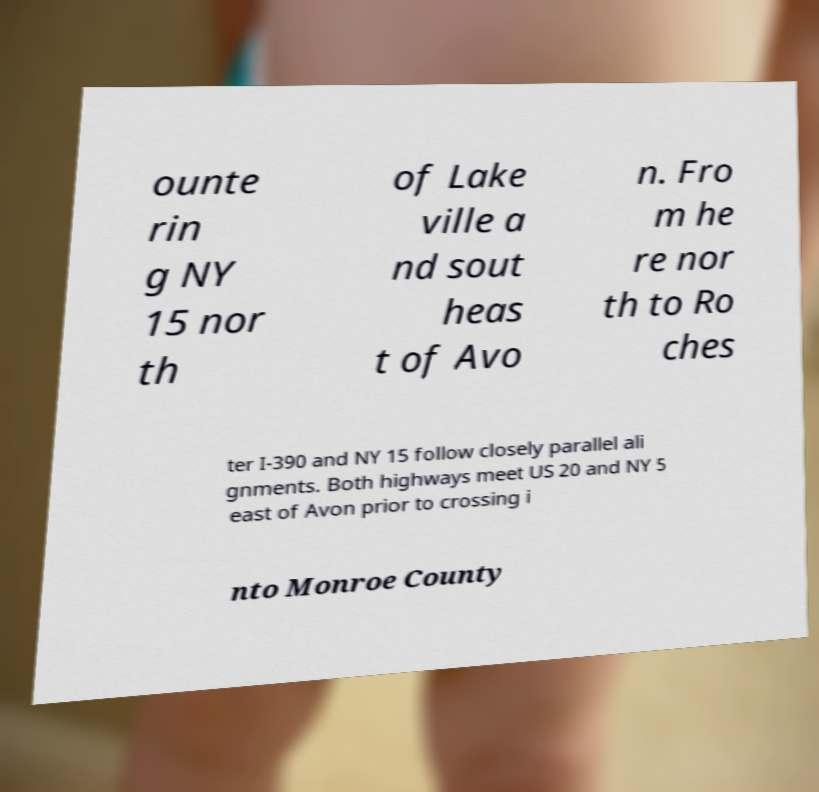Can you read and provide the text displayed in the image?This photo seems to have some interesting text. Can you extract and type it out for me? ounte rin g NY 15 nor th of Lake ville a nd sout heas t of Avo n. Fro m he re nor th to Ro ches ter I-390 and NY 15 follow closely parallel ali gnments. Both highways meet US 20 and NY 5 east of Avon prior to crossing i nto Monroe County 